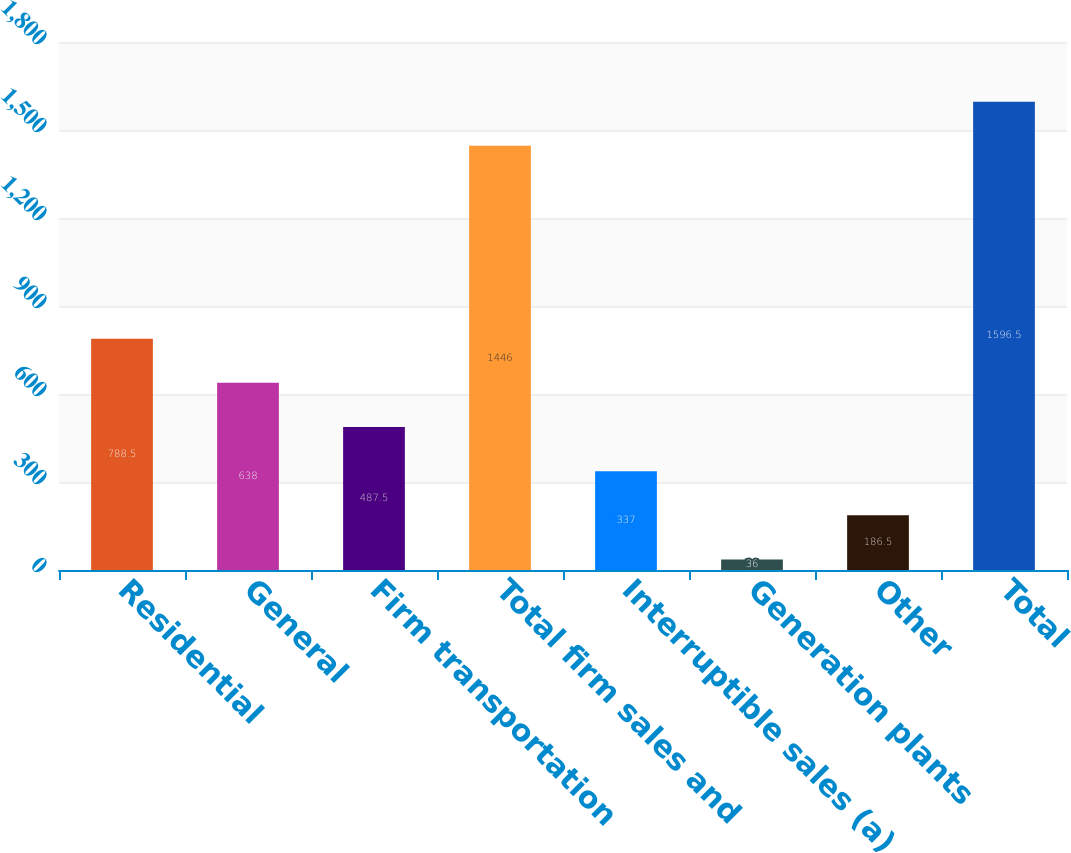<chart> <loc_0><loc_0><loc_500><loc_500><bar_chart><fcel>Residential<fcel>General<fcel>Firm transportation<fcel>Total firm sales and<fcel>Interruptible sales (a)<fcel>Generation plants<fcel>Other<fcel>Total<nl><fcel>788.5<fcel>638<fcel>487.5<fcel>1446<fcel>337<fcel>36<fcel>186.5<fcel>1596.5<nl></chart> 